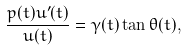<formula> <loc_0><loc_0><loc_500><loc_500>\frac { p ( t ) u ^ { \prime } ( t ) } { u ( t ) } = \gamma ( t ) \tan \theta ( t ) ,</formula> 